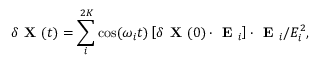<formula> <loc_0><loc_0><loc_500><loc_500>\delta X ( t ) = \sum _ { i } ^ { 2 K } \cos ( \omega _ { i } t ) \left [ \delta X ( 0 ) \cdot E _ { i } \right ] \cdot E _ { i } / E _ { i } ^ { 2 } ,</formula> 